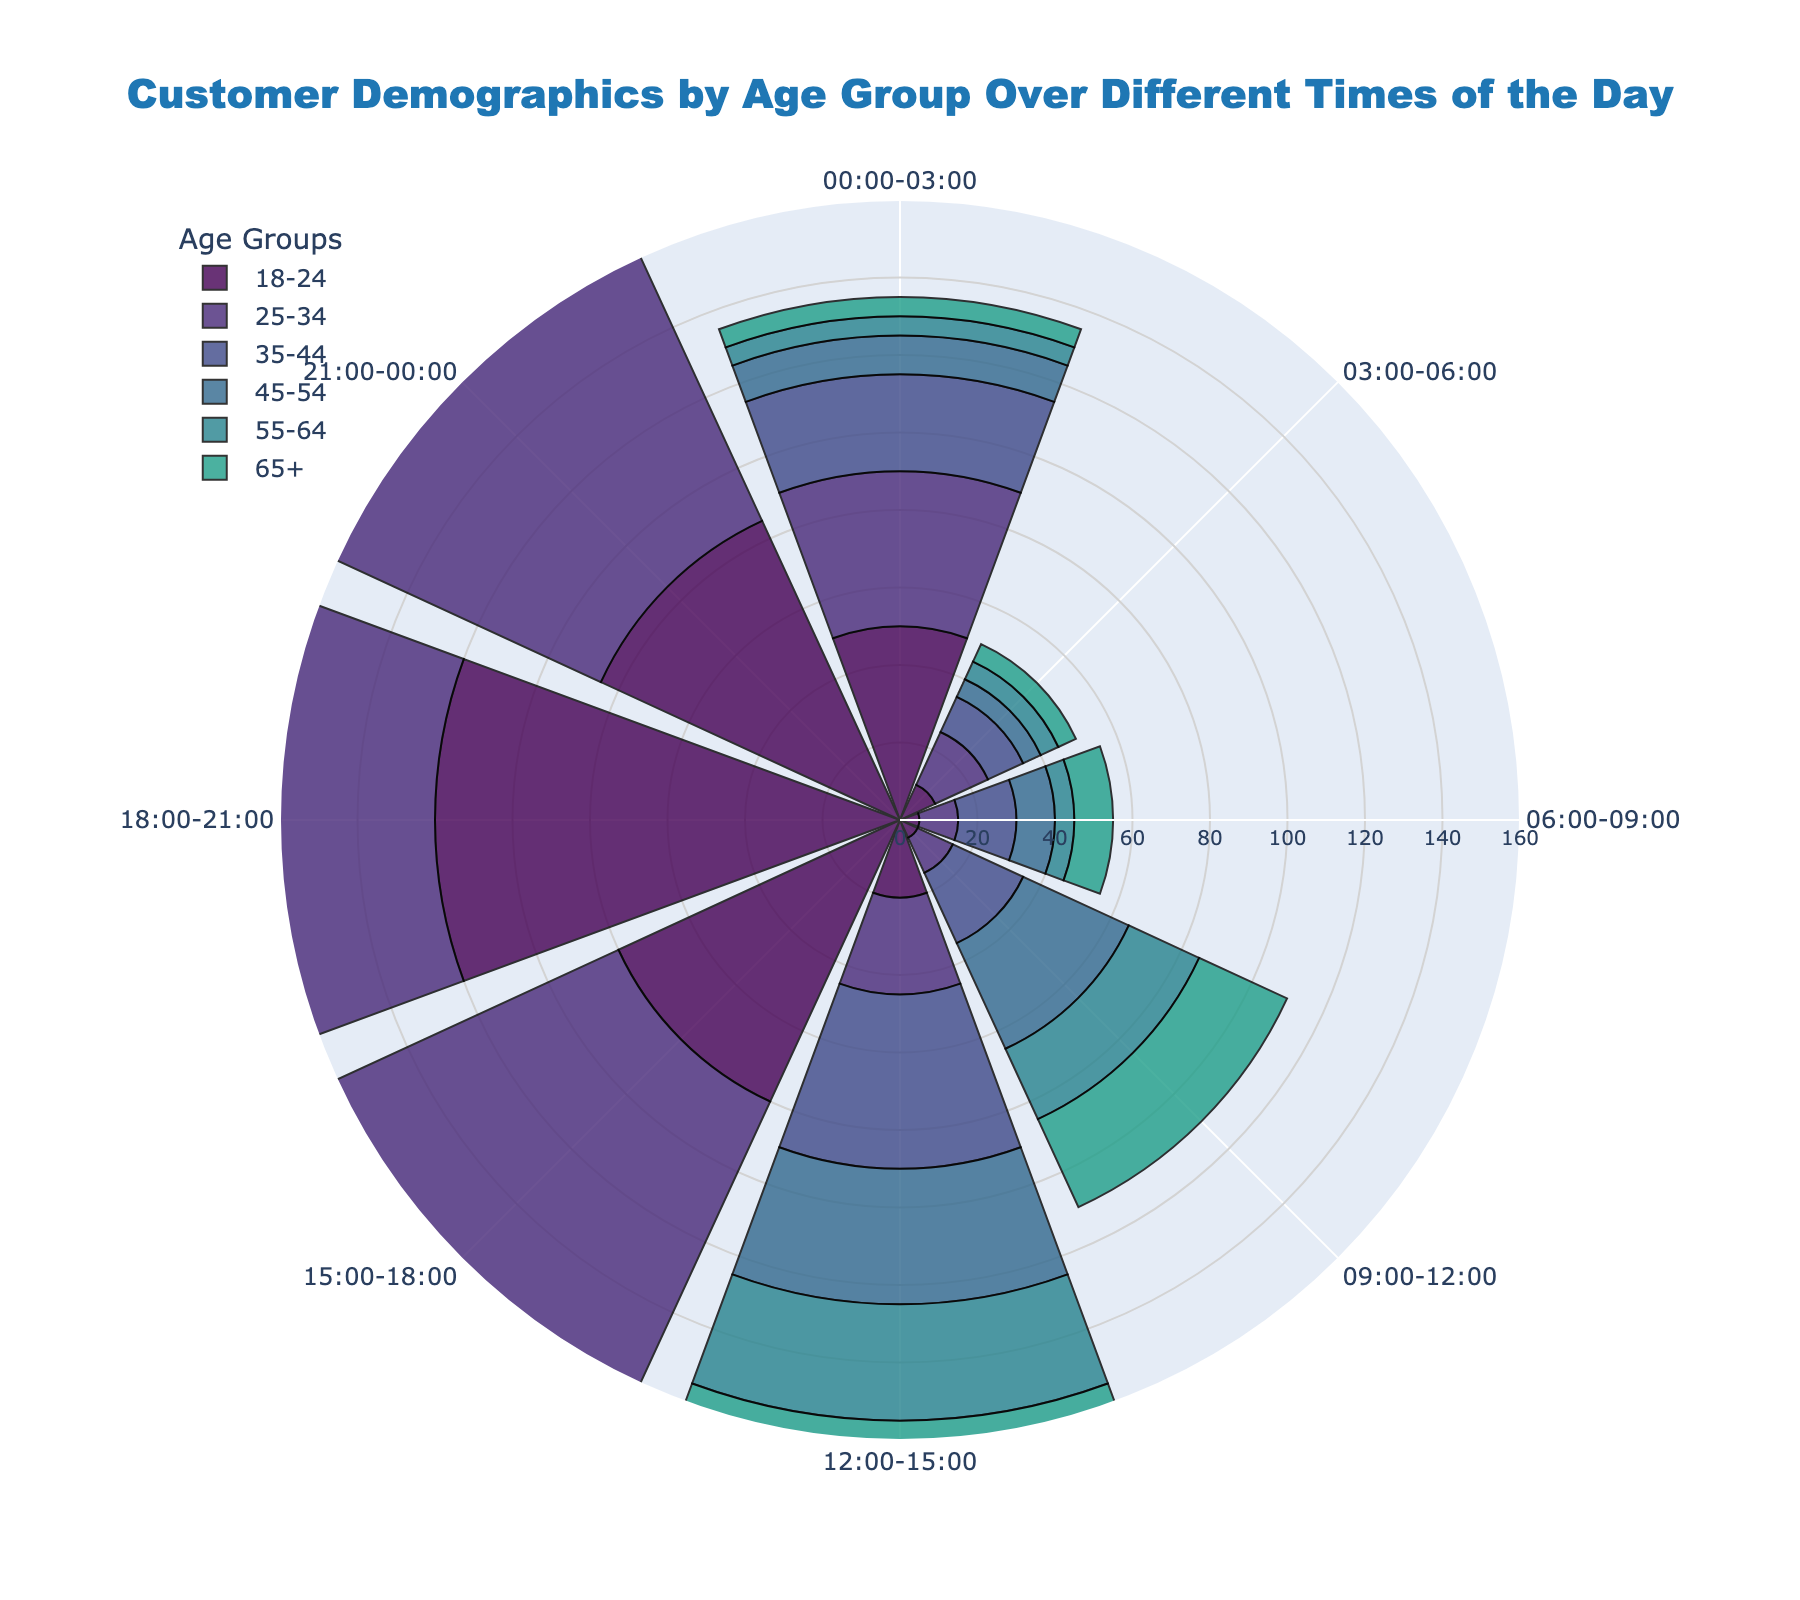What's the title of the rose chart? The title of the chart is usually located at the top center. In this figure, the title text reads "Customer Demographics by Age Group Over Different Times of the Day".
Answer: Customer Demographics by Age Group Over Different Times of the Day What time slot sees the highest number of 25-34 year-olds? To find this, look at the bar with the highest radial distance within the segment labeled for 25-34 age group. The longest bar for 25-34 year-olds appears at the 18:00-21:00 time slot.
Answer: 18:00-21:00 Which age group has the smallest representation in the 03:00-06:00 time slot? Look for the shortest bar in the segment labeled 03:00-06:00. All age groups have relatively low values, but the 45-54, 55-64, and 65+ age groups each have the smallest value of 5, indicating equal representation.
Answer: 45-54, 55-64, 65+ How many total customers aged 18-24 visit between 00:00 and 06:00? Add the values for the 18-24 age group for the 00:00-03:00 and 03:00-06:00 time slots: 50 + 10.
Answer: 60 Which age group has the second highest number of visitors in the 15:00-18:00 time slot? Find the respective bar lengths for each age group in the 15:00-18:00 time slot and identify the second longest one. The longest is for 25-34, followed by 18-24.
Answer: 18-24 Compare the number of visitors aged 35-44 and 45-54 between 09:00 and 12:00. Which group is more and by how much? For the 35-44 age group, the value is 20. For the 45-54 age group, the value is 30. The difference is 30 - 20.
Answer: 45-54, 10 Between the age groups 55-64 and 65+, which group has more visitors on average across all time slots? Calculate the average for each age group across all time slots: 
Sum of 55-64: 5 + 5 + 5 + 20 + 30 + 35 + 40 + 25 = 165. 
Sum of 65+: 5 + 5 + 10 + 25 + 40 + 30 + 20 + 10 = 145. 
Average for 55-64: 165 / 8 = 20.625,
Average for 65+: 145 / 8 = 18.125.
55-64 has a higher average.
Answer: 55-64, 20.625 What is the total number of visitors for the 35-44 age group over the entire day? Sum the values for the 35-44 age group across all time slots: 25 + 10 + 15 + 20 + 45 + 70 + 95 + 55.
Answer: 335 Which time slot has the least variation in the number of visitors across all age groups? Look for the time slot where the bars are closest in length; 03:00-06:00 has relatively low and similar values across age groups.
Answer: 03:00-06:00 